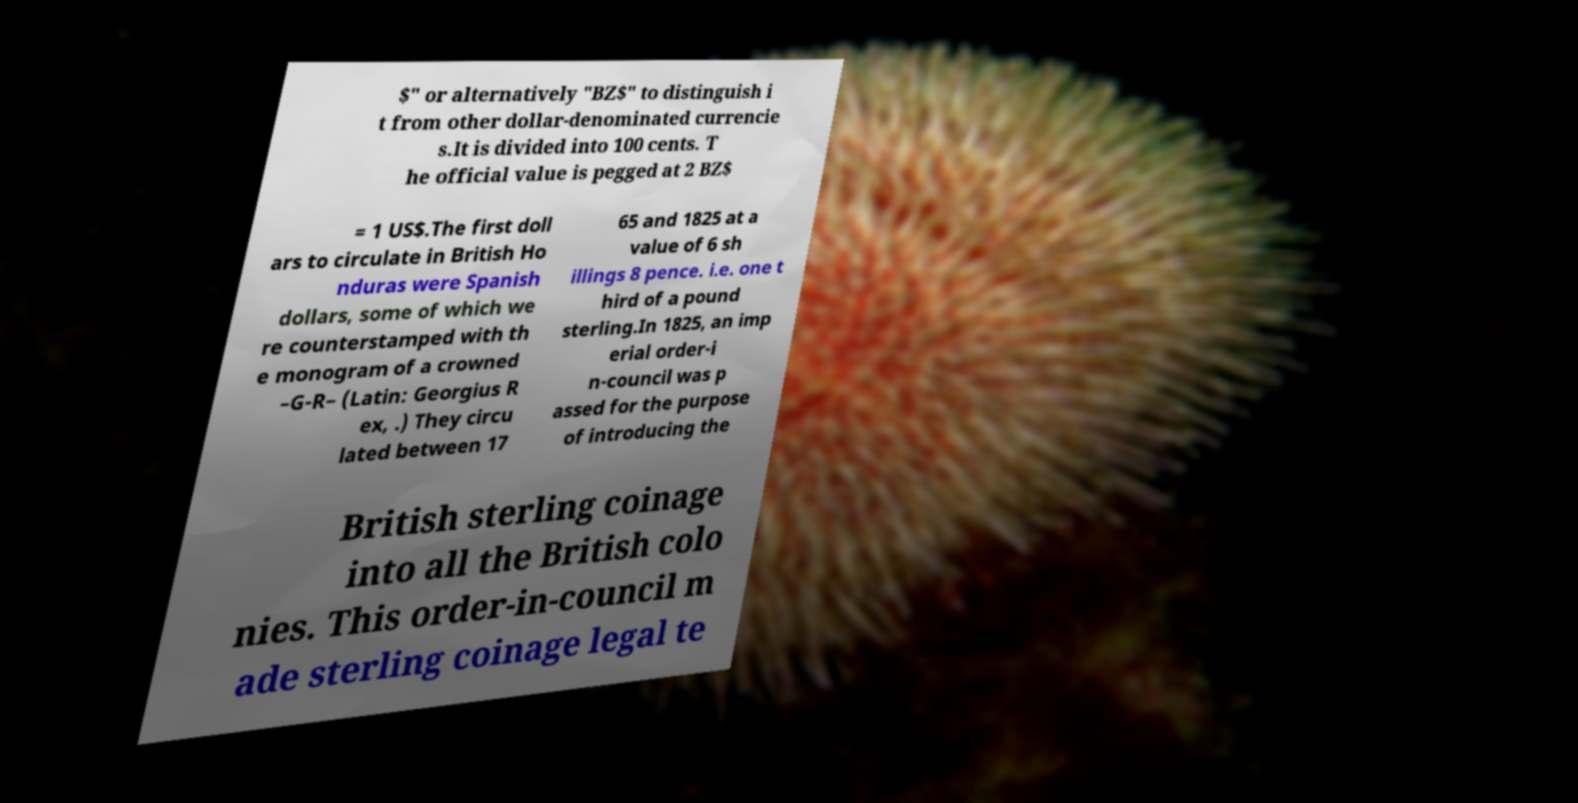For documentation purposes, I need the text within this image transcribed. Could you provide that? $" or alternatively "BZ$" to distinguish i t from other dollar-denominated currencie s.It is divided into 100 cents. T he official value is pegged at 2 BZ$ = 1 US$.The first doll ars to circulate in British Ho nduras were Spanish dollars, some of which we re counterstamped with th e monogram of a crowned –G-R– (Latin: Georgius R ex, .) They circu lated between 17 65 and 1825 at a value of 6 sh illings 8 pence. i.e. one t hird of a pound sterling.In 1825, an imp erial order-i n-council was p assed for the purpose of introducing the British sterling coinage into all the British colo nies. This order-in-council m ade sterling coinage legal te 